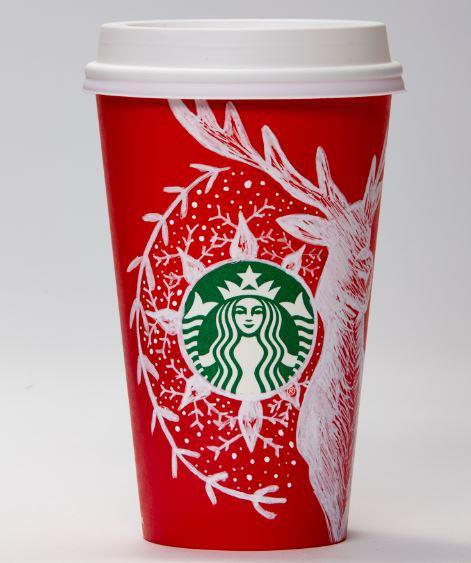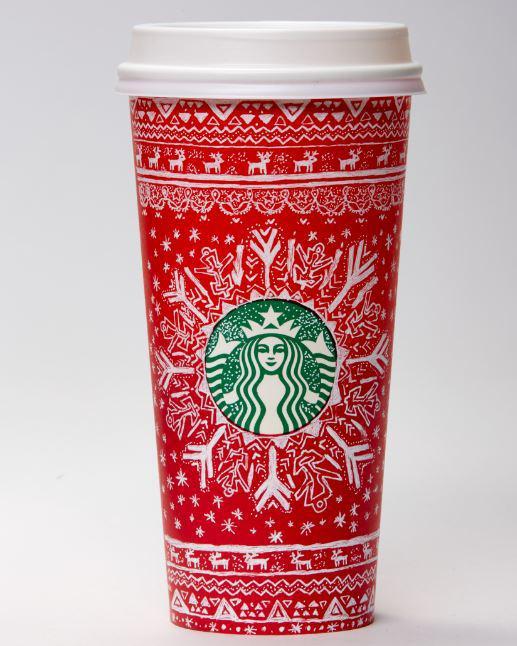The first image is the image on the left, the second image is the image on the right. Analyze the images presented: Is the assertion "There are exactly two cups." valid? Answer yes or no. Yes. 